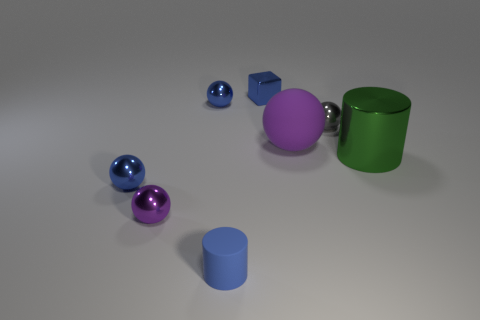How many purple spheres must be subtracted to get 1 purple spheres? 1 Subtract all gray balls. How many balls are left? 4 Subtract all purple matte spheres. How many spheres are left? 4 Subtract all red cylinders. Subtract all gray cubes. How many cylinders are left? 2 Add 2 tiny red rubber spheres. How many objects exist? 10 Subtract all blocks. How many objects are left? 7 Add 3 gray shiny things. How many gray shiny things are left? 4 Add 2 tiny cubes. How many tiny cubes exist? 3 Subtract 0 purple cubes. How many objects are left? 8 Subtract all big purple matte objects. Subtract all purple metal spheres. How many objects are left? 6 